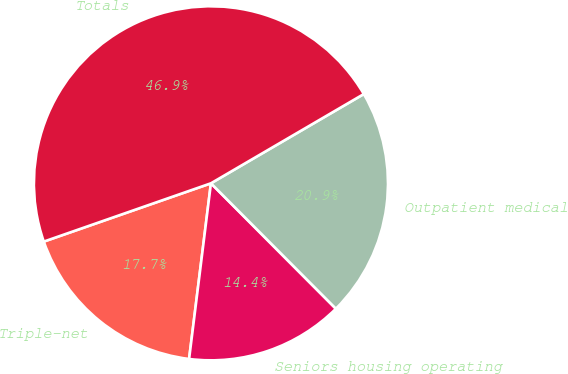<chart> <loc_0><loc_0><loc_500><loc_500><pie_chart><fcel>Triple-net<fcel>Seniors housing operating<fcel>Outpatient medical<fcel>Totals<nl><fcel>17.69%<fcel>14.44%<fcel>20.94%<fcel>46.93%<nl></chart> 